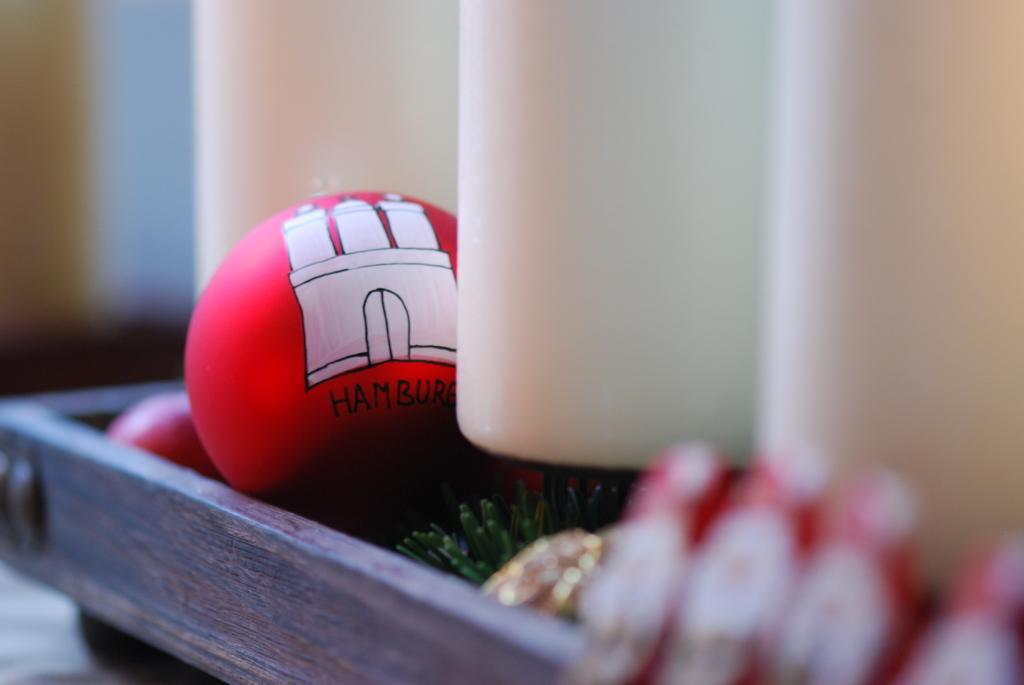What objects are present in the image? There are balls in the image. Can you describe the background of the image? The background of the image is blurry. Are there any words or letters on any of the balls? Yes, there is text on at least one of the balls. What type of cable can be seen connecting the balls in the image? There is no cable connecting the balls in the image; the balls are separate objects. 